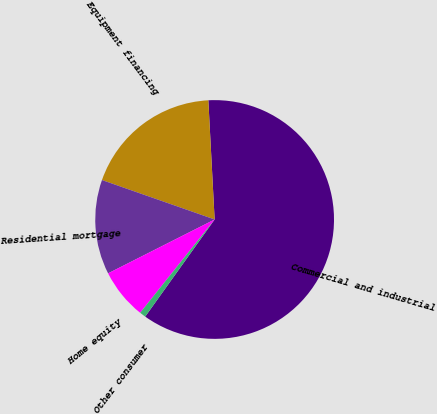Convert chart to OTSL. <chart><loc_0><loc_0><loc_500><loc_500><pie_chart><fcel>Commercial and industrial<fcel>Equipment financing<fcel>Residential mortgage<fcel>Home equity<fcel>Other consumer<nl><fcel>60.72%<fcel>18.8%<fcel>12.81%<fcel>6.83%<fcel>0.84%<nl></chart> 